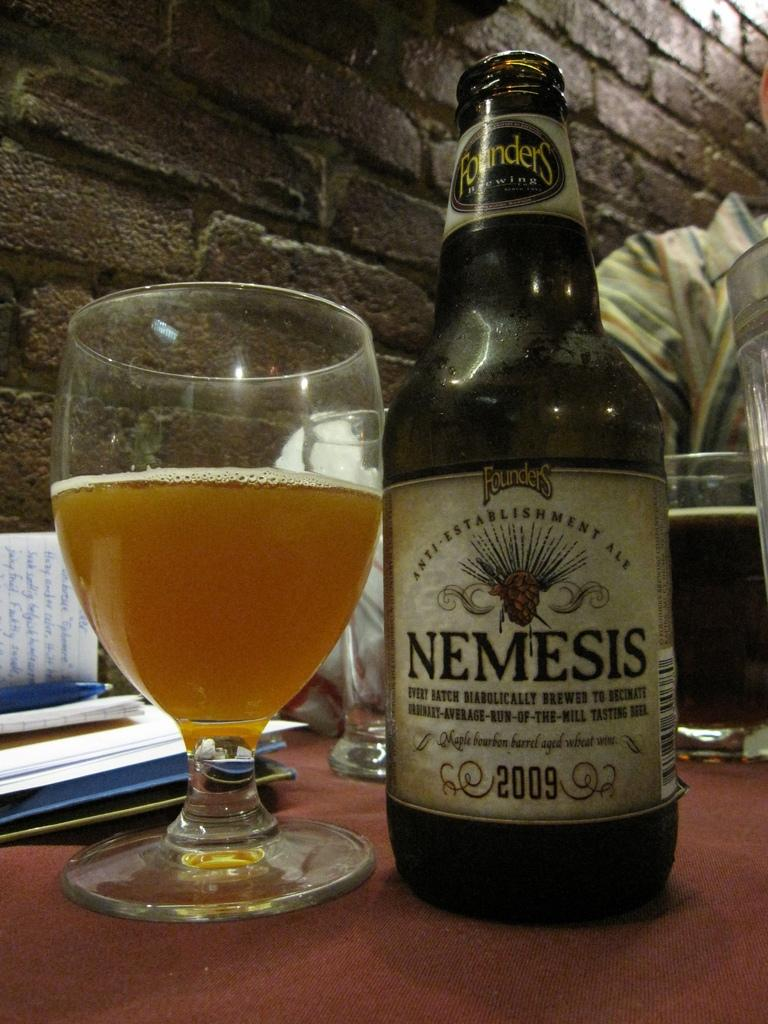<image>
Write a terse but informative summary of the picture. An open bottle of beer called Nemesis sits next to a glass of beer on a table. 